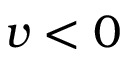Convert formula to latex. <formula><loc_0><loc_0><loc_500><loc_500>v < 0</formula> 